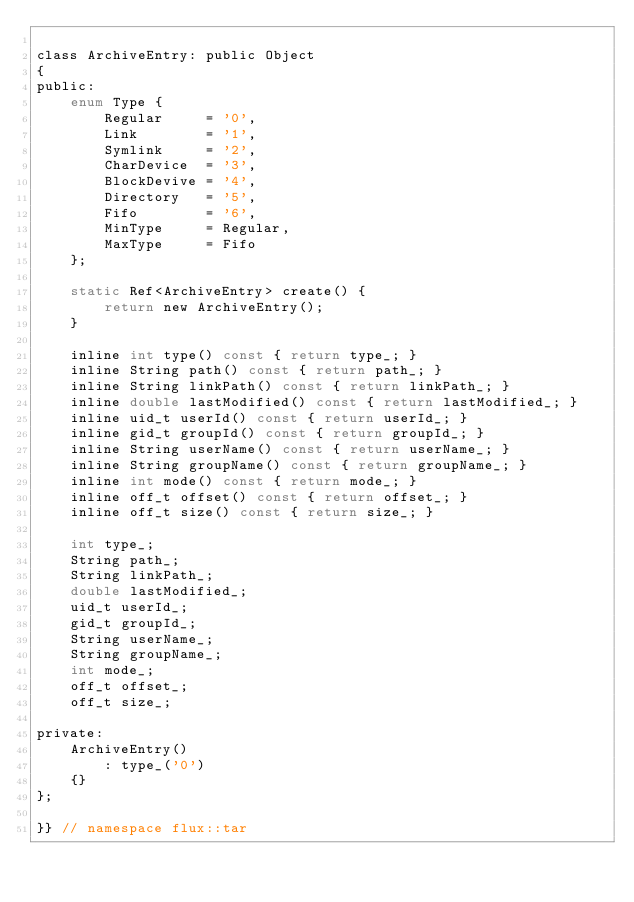Convert code to text. <code><loc_0><loc_0><loc_500><loc_500><_C_>
class ArchiveEntry: public Object
{
public:
    enum Type {
        Regular     = '0',
        Link        = '1',
        Symlink     = '2',
        CharDevice  = '3',
        BlockDevive = '4',
        Directory   = '5',
        Fifo        = '6',
        MinType     = Regular,
        MaxType     = Fifo
    };

    static Ref<ArchiveEntry> create() {
        return new ArchiveEntry();
    }

    inline int type() const { return type_; }
    inline String path() const { return path_; }
    inline String linkPath() const { return linkPath_; }
    inline double lastModified() const { return lastModified_; }
    inline uid_t userId() const { return userId_; }
    inline gid_t groupId() const { return groupId_; }
    inline String userName() const { return userName_; }
    inline String groupName() const { return groupName_; }
    inline int mode() const { return mode_; }
    inline off_t offset() const { return offset_; }
    inline off_t size() const { return size_; }

    int type_;
    String path_;
    String linkPath_;
    double lastModified_;
    uid_t userId_;
    gid_t groupId_;
    String userName_;
    String groupName_;
    int mode_;
    off_t offset_;
    off_t size_;

private:
    ArchiveEntry()
        : type_('0')
    {}
};

}} // namespace flux::tar
</code> 